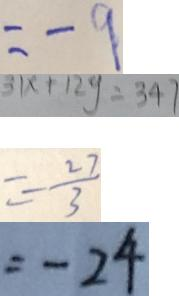Convert formula to latex. <formula><loc_0><loc_0><loc_500><loc_500>= - 9 
 3 1 x + 1 2 y = 3 4 7 
 = - \frac { 2 7 } { 3 } 
 = - 2 4</formula> 